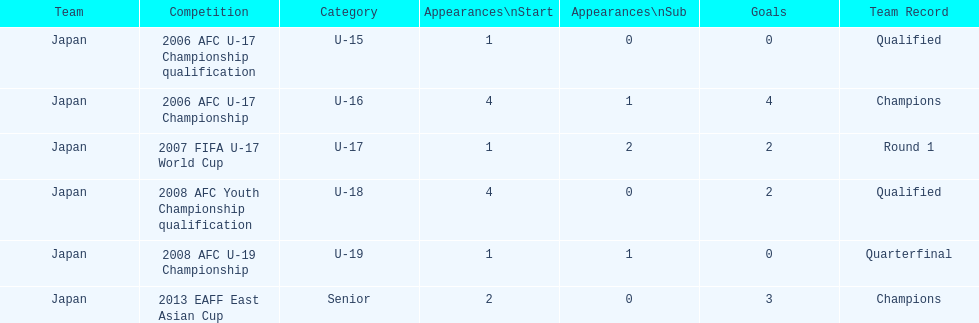In which location did japan manage to score just four goals? 2006 AFC U-17 Championship. 